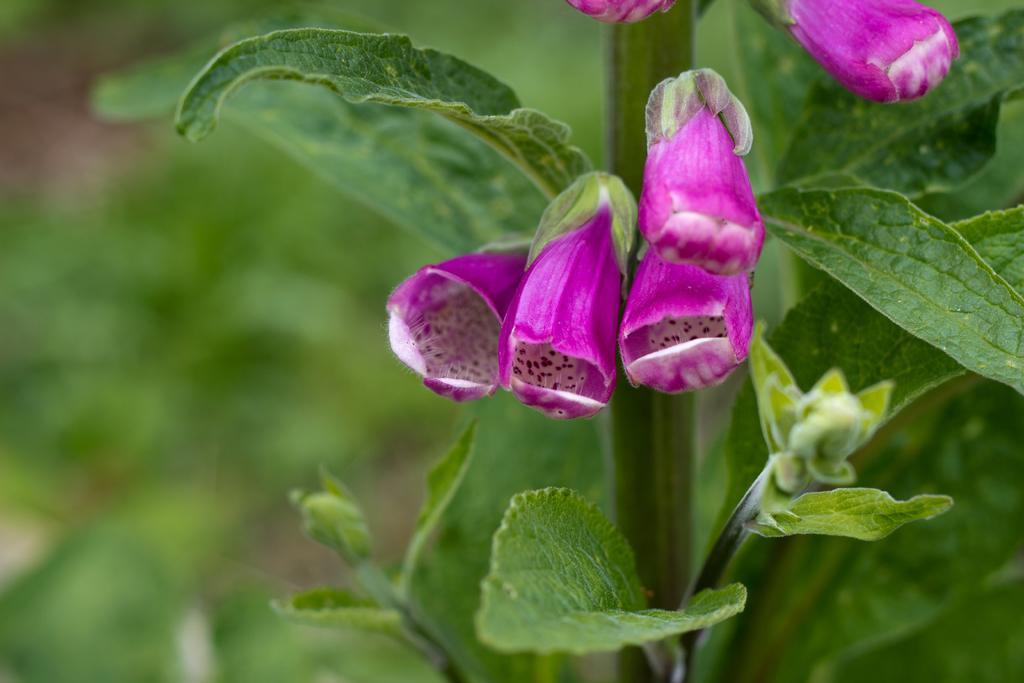Describe this image in one or two sentences. In this image there is a plant having flowers, buds and leaves. Background is blurry. 